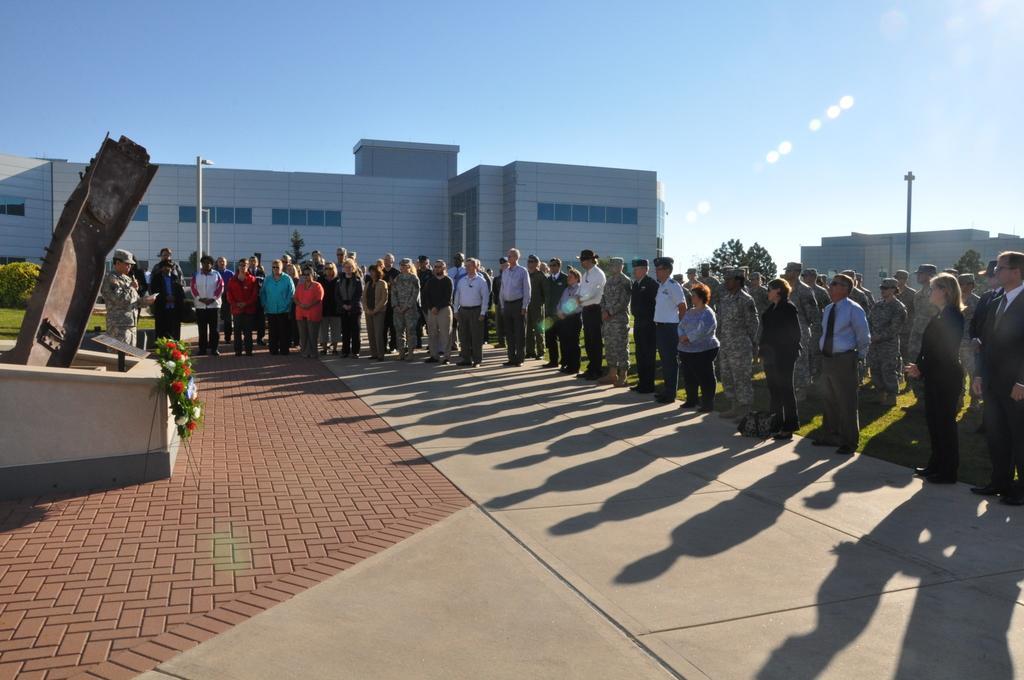In one or two sentences, can you explain what this image depicts? In this image I can see the group of people with different color dresses and few people with caps. In -front of these people I can see an object and there are flowers which are in red and white color. In the background I can see the poles, buildings, trees and the sky. 